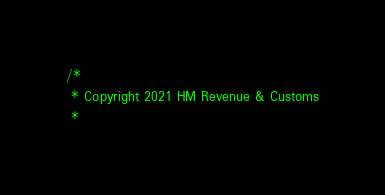Convert code to text. <code><loc_0><loc_0><loc_500><loc_500><_Scala_>/*
 * Copyright 2021 HM Revenue & Customs
 *</code> 